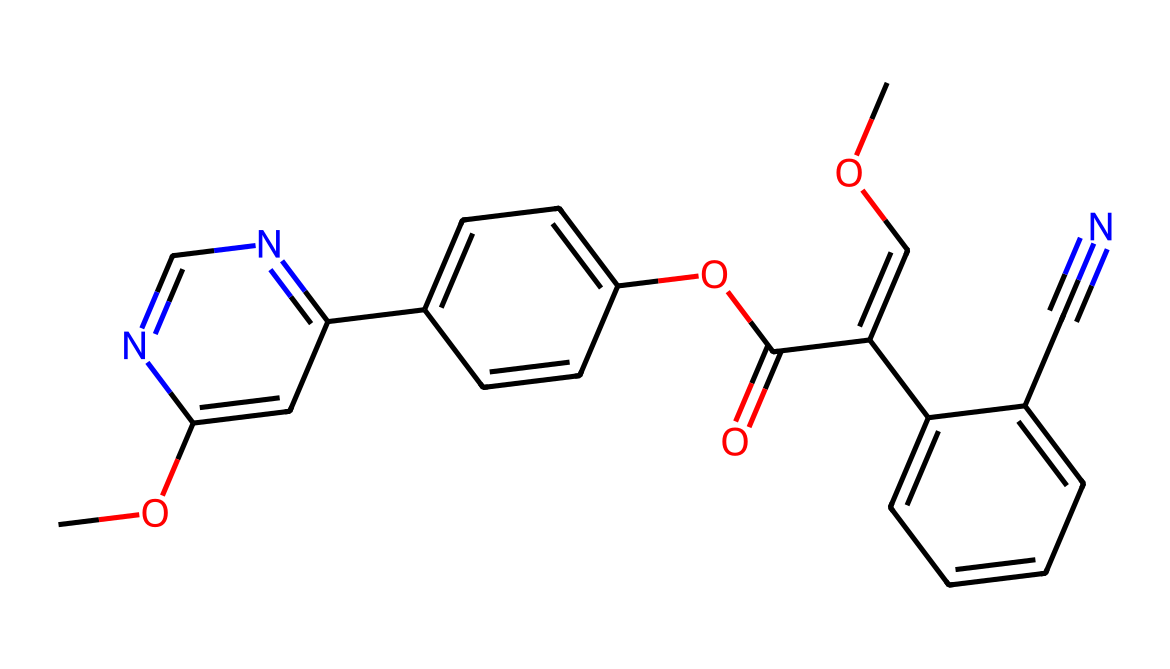How many rings are present in the chemical structure of azoxystrobin? By analyzing the structure, I can identify that there are three distinct ring structures visualized within the SMILES representation: the first ring is noted within the C1=CC=CC=C1 segment, the second ring appears in the C2=CC=C(C=C2) part, and the last ring is seen in the C3=NC=NC(=C3) portion.
Answer: 3 What functional groups are present in azoxystrobin? Observing the SMILES, I count several functional groups: an ether group (–O–) is indicated by instances of O surrounded by carbons. There are ester groups (–COOC–) identified from "C(=O)OC". There's also a nitrile group (–C≡N) as seen in "C#N".
Answer: ether, ester, nitrile What is the molecular formula for azoxystrobin? To determine the molecular formula, I summarize all the distinct atoms from the SMILES representation. I count: carbon (C), hydrogen (H), oxygen (O), and nitrogen (N) atoms. Each count reveals there are 18 carbons, 20 hydrogens, 4 oxygens, and 4 nitrogens leading to the molecular formula being C18H20N4O4.
Answer: C18H20N4O4 Does azoxystrobin contain nitrogen atoms? The presence of nitrogen is evident in two parts of the structure shown in the SMILES: the "C#N" portion defines a nitrile functional group, and the "NC=NC" segment indicates nitrogen atoms within rings. Thus, at least four nitrogen atoms can be identified.
Answer: yes What type of compounds does azoxystrobin belong to? Given that azoxystrobin is utilized primarily for its antifungal properties, it can be categorized as a synthetic fungicide based upon its chemical structure and functional groups that target fungal pathogens.
Answer: fungicide What is the significance of the nitrile group in the structure of azoxystrobin? The nitrile group (–C≡N) typically contributes to the biological activity of azoxystrobin. This functional group is known to enhance the molecule's ability to inhibit enzymes critical to fungal growth, therefore aiding the overall antifungal efficacy.
Answer: antifungal activity 